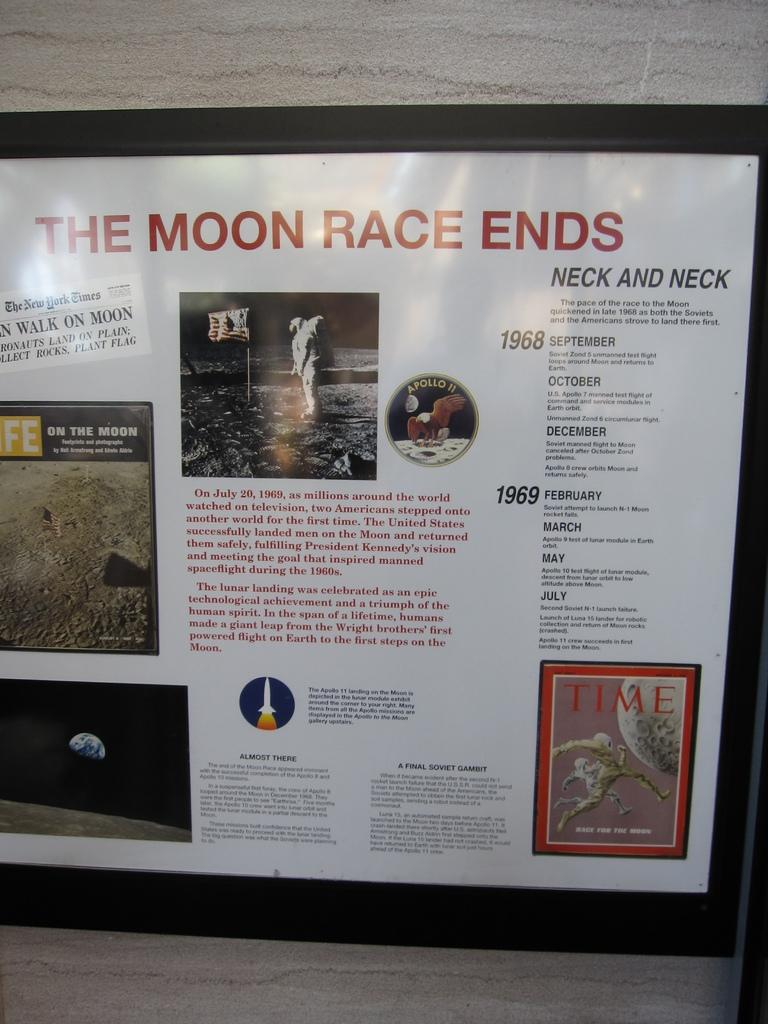<image>
Offer a succinct explanation of the picture presented. A sign about the moon race features a timeline of events in 1968 and 1969. 